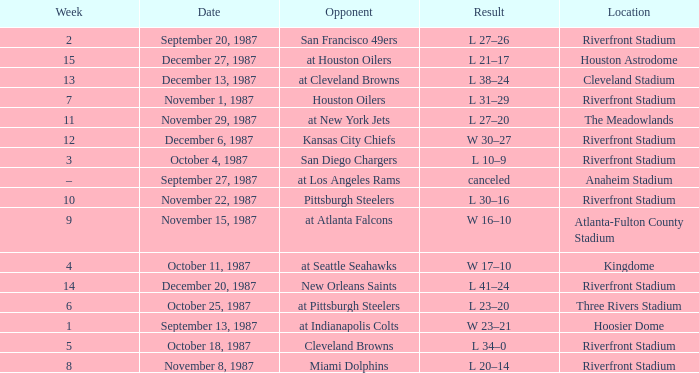What was the result of the game at the Riverfront Stadium after week 8? L 20–14. 